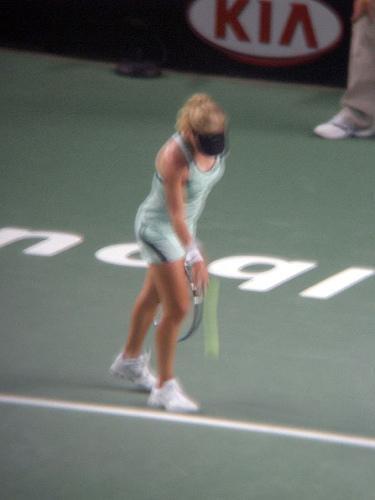How many people are in the picture?
Give a very brief answer. 3. 